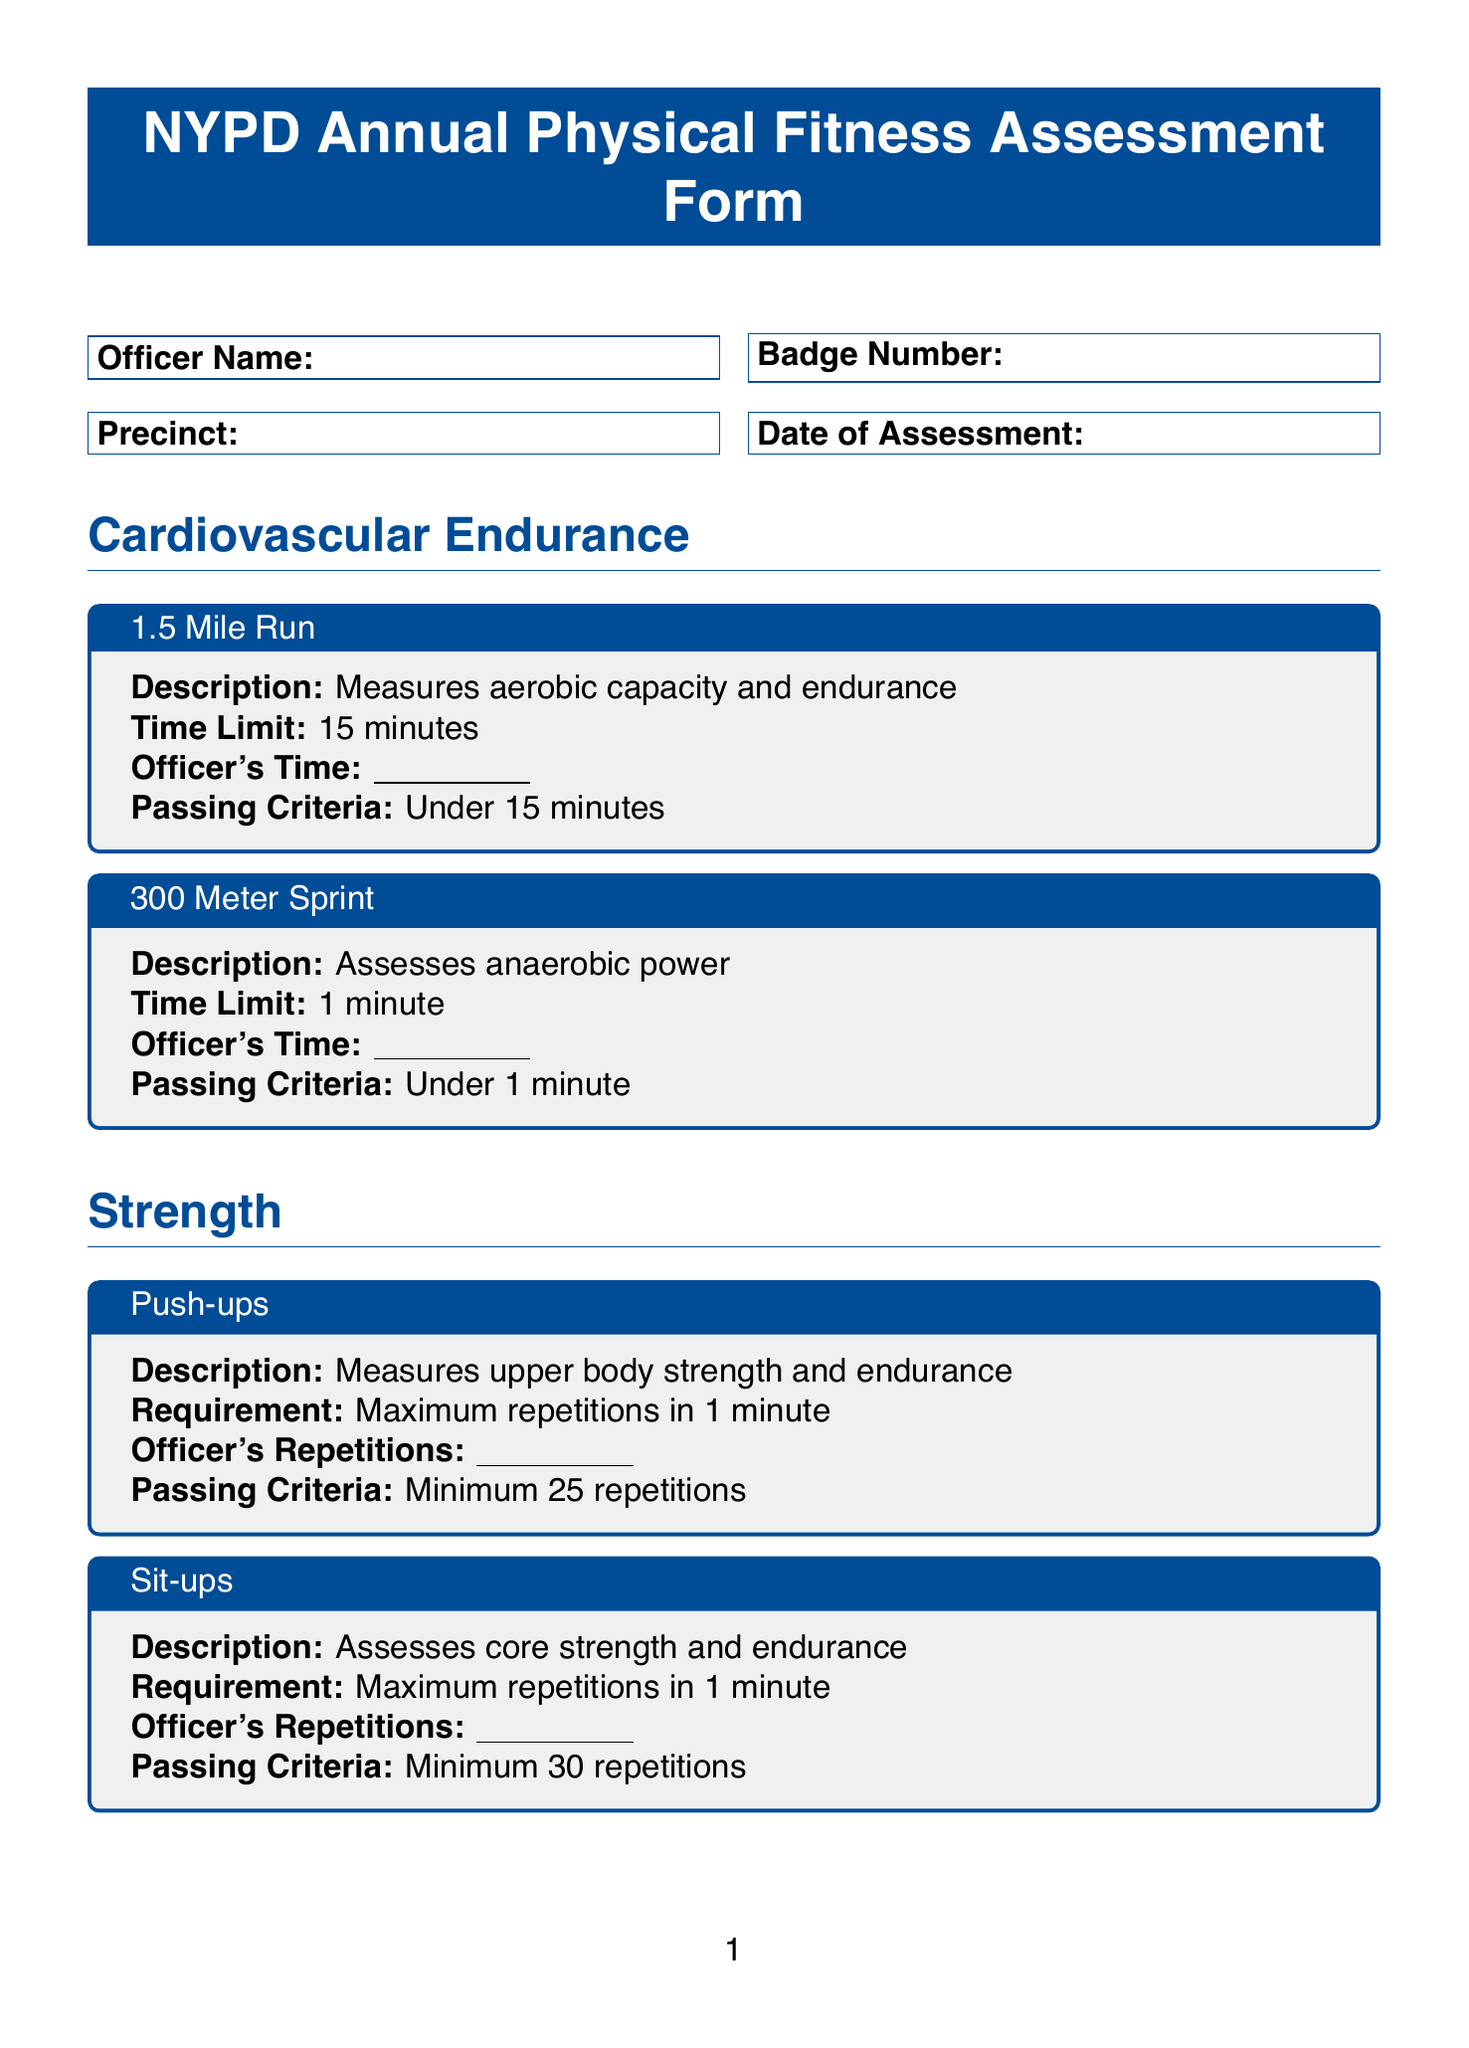What is the title of the document? The title is the first thing presented in the document, indicating its purpose and type.
Answer: NYPD Annual Physical Fitness Assessment Form What is the passing criteria for the 1.5 Mile Run? The passing criteria are stated clearly under the test description, indicating what qualifies an officer to pass.
Answer: Under 15 minutes What is the minimum number of push-ups required? The requirement for push-ups is specified in the strength section, indicating the minimum acceptable performance.
Answer: Minimum 25 repetitions What is the distance needed to pass the Sit and Reach Test? The passing criteria for the flexibility test outlines the distance that must be reached for an officer to qualify.
Answer: Minimum 14 inches How many total tests are listed under Strength? Counting the tests listed in the strength section shows the total number of unique assessments for strength.
Answer: 3 What happens if an officer fails to meet the standards? Additional notes explain the consequences of not meeting the fitness standards outlined in the document.
Answer: Attend remedial fitness training What is the requirement for the Bench Press test? The requirement for the Bench Press is provided in the strength section, explaining how to assess performance.
Answer: Percentage of body weight Who signs the certification section of the form? The certification section specifies individuals responsible for signing off on the assessment.
Answer: Officer and Assessor What color is used for the title section of the document? The document specifies the color used for the title in the formatting section, indicating visual styling choices.
Answer: NYPD Blue 